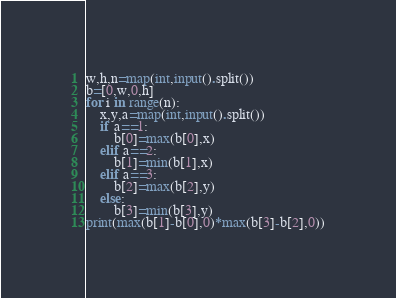<code> <loc_0><loc_0><loc_500><loc_500><_Python_>w,h,n=map(int,input().split())
b=[0,w,0,h]
for i in range(n):
    x,y,a=map(int,input().split())
    if a==1:
        b[0]=max(b[0],x)
    elif a==2:
        b[1]=min(b[1],x)
    elif a==3:
        b[2]=max(b[2],y)
    else:
        b[3]=min(b[3],y)
print(max(b[1]-b[0],0)*max(b[3]-b[2],0))</code> 